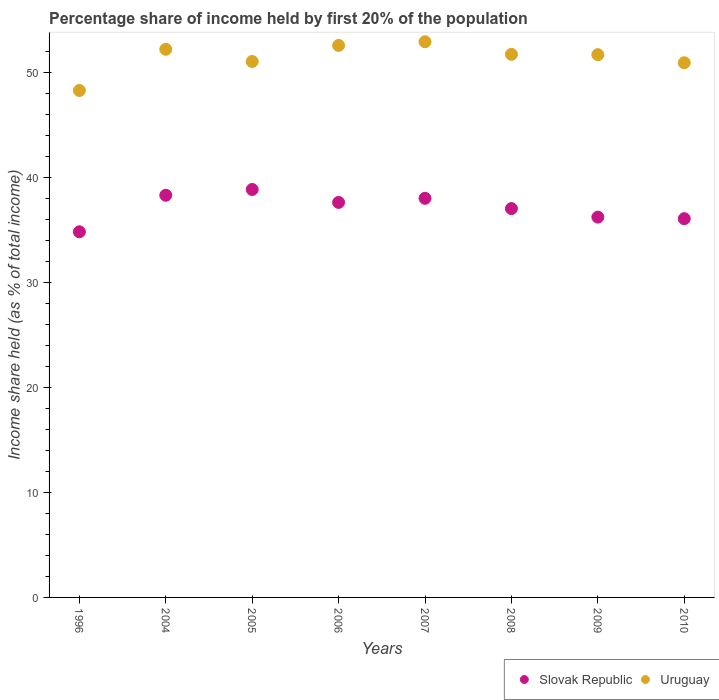How many different coloured dotlines are there?
Provide a short and direct response. 2. What is the share of income held by first 20% of the population in Uruguay in 2009?
Give a very brief answer. 51.69. Across all years, what is the maximum share of income held by first 20% of the population in Uruguay?
Provide a short and direct response. 52.92. Across all years, what is the minimum share of income held by first 20% of the population in Slovak Republic?
Your response must be concise. 34.82. What is the total share of income held by first 20% of the population in Slovak Republic in the graph?
Your answer should be very brief. 296.92. What is the difference between the share of income held by first 20% of the population in Slovak Republic in 2006 and that in 2007?
Give a very brief answer. -0.39. What is the difference between the share of income held by first 20% of the population in Slovak Republic in 2005 and the share of income held by first 20% of the population in Uruguay in 2007?
Keep it short and to the point. -14.07. What is the average share of income held by first 20% of the population in Slovak Republic per year?
Give a very brief answer. 37.11. In the year 2010, what is the difference between the share of income held by first 20% of the population in Slovak Republic and share of income held by first 20% of the population in Uruguay?
Offer a very short reply. -14.85. In how many years, is the share of income held by first 20% of the population in Slovak Republic greater than 48 %?
Provide a short and direct response. 0. What is the ratio of the share of income held by first 20% of the population in Uruguay in 2009 to that in 2010?
Your answer should be very brief. 1.02. Is the share of income held by first 20% of the population in Slovak Republic in 1996 less than that in 2007?
Your answer should be compact. Yes. Is the difference between the share of income held by first 20% of the population in Slovak Republic in 2005 and 2006 greater than the difference between the share of income held by first 20% of the population in Uruguay in 2005 and 2006?
Offer a very short reply. Yes. What is the difference between the highest and the second highest share of income held by first 20% of the population in Uruguay?
Make the answer very short. 0.35. What is the difference between the highest and the lowest share of income held by first 20% of the population in Uruguay?
Provide a short and direct response. 4.64. In how many years, is the share of income held by first 20% of the population in Slovak Republic greater than the average share of income held by first 20% of the population in Slovak Republic taken over all years?
Provide a succinct answer. 4. Is the sum of the share of income held by first 20% of the population in Uruguay in 2005 and 2008 greater than the maximum share of income held by first 20% of the population in Slovak Republic across all years?
Provide a short and direct response. Yes. Is the share of income held by first 20% of the population in Slovak Republic strictly less than the share of income held by first 20% of the population in Uruguay over the years?
Ensure brevity in your answer.  Yes. How many dotlines are there?
Make the answer very short. 2. How many years are there in the graph?
Your answer should be compact. 8. Are the values on the major ticks of Y-axis written in scientific E-notation?
Your answer should be very brief. No. Where does the legend appear in the graph?
Offer a terse response. Bottom right. What is the title of the graph?
Offer a terse response. Percentage share of income held by first 20% of the population. What is the label or title of the X-axis?
Provide a short and direct response. Years. What is the label or title of the Y-axis?
Provide a succinct answer. Income share held (as % of total income). What is the Income share held (as % of total income) of Slovak Republic in 1996?
Offer a very short reply. 34.82. What is the Income share held (as % of total income) of Uruguay in 1996?
Offer a very short reply. 48.28. What is the Income share held (as % of total income) in Slovak Republic in 2004?
Offer a terse response. 38.3. What is the Income share held (as % of total income) in Uruguay in 2004?
Your answer should be compact. 52.2. What is the Income share held (as % of total income) in Slovak Republic in 2005?
Your response must be concise. 38.85. What is the Income share held (as % of total income) in Uruguay in 2005?
Offer a terse response. 51.04. What is the Income share held (as % of total income) of Slovak Republic in 2006?
Offer a very short reply. 37.62. What is the Income share held (as % of total income) in Uruguay in 2006?
Provide a short and direct response. 52.57. What is the Income share held (as % of total income) of Slovak Republic in 2007?
Provide a short and direct response. 38.01. What is the Income share held (as % of total income) of Uruguay in 2007?
Give a very brief answer. 52.92. What is the Income share held (as % of total income) of Slovak Republic in 2008?
Make the answer very short. 37.03. What is the Income share held (as % of total income) of Uruguay in 2008?
Make the answer very short. 51.72. What is the Income share held (as % of total income) in Slovak Republic in 2009?
Keep it short and to the point. 36.22. What is the Income share held (as % of total income) in Uruguay in 2009?
Your answer should be very brief. 51.69. What is the Income share held (as % of total income) of Slovak Republic in 2010?
Give a very brief answer. 36.07. What is the Income share held (as % of total income) of Uruguay in 2010?
Offer a terse response. 50.92. Across all years, what is the maximum Income share held (as % of total income) of Slovak Republic?
Offer a very short reply. 38.85. Across all years, what is the maximum Income share held (as % of total income) of Uruguay?
Your response must be concise. 52.92. Across all years, what is the minimum Income share held (as % of total income) of Slovak Republic?
Your response must be concise. 34.82. Across all years, what is the minimum Income share held (as % of total income) in Uruguay?
Provide a short and direct response. 48.28. What is the total Income share held (as % of total income) of Slovak Republic in the graph?
Your answer should be compact. 296.92. What is the total Income share held (as % of total income) of Uruguay in the graph?
Give a very brief answer. 411.34. What is the difference between the Income share held (as % of total income) of Slovak Republic in 1996 and that in 2004?
Offer a very short reply. -3.48. What is the difference between the Income share held (as % of total income) in Uruguay in 1996 and that in 2004?
Offer a terse response. -3.92. What is the difference between the Income share held (as % of total income) of Slovak Republic in 1996 and that in 2005?
Keep it short and to the point. -4.03. What is the difference between the Income share held (as % of total income) in Uruguay in 1996 and that in 2005?
Your answer should be compact. -2.76. What is the difference between the Income share held (as % of total income) in Uruguay in 1996 and that in 2006?
Your answer should be very brief. -4.29. What is the difference between the Income share held (as % of total income) of Slovak Republic in 1996 and that in 2007?
Keep it short and to the point. -3.19. What is the difference between the Income share held (as % of total income) of Uruguay in 1996 and that in 2007?
Your response must be concise. -4.64. What is the difference between the Income share held (as % of total income) in Slovak Republic in 1996 and that in 2008?
Provide a succinct answer. -2.21. What is the difference between the Income share held (as % of total income) of Uruguay in 1996 and that in 2008?
Provide a short and direct response. -3.44. What is the difference between the Income share held (as % of total income) of Uruguay in 1996 and that in 2009?
Your answer should be compact. -3.41. What is the difference between the Income share held (as % of total income) in Slovak Republic in 1996 and that in 2010?
Offer a terse response. -1.25. What is the difference between the Income share held (as % of total income) in Uruguay in 1996 and that in 2010?
Your response must be concise. -2.64. What is the difference between the Income share held (as % of total income) in Slovak Republic in 2004 and that in 2005?
Ensure brevity in your answer.  -0.55. What is the difference between the Income share held (as % of total income) of Uruguay in 2004 and that in 2005?
Your answer should be very brief. 1.16. What is the difference between the Income share held (as % of total income) in Slovak Republic in 2004 and that in 2006?
Your response must be concise. 0.68. What is the difference between the Income share held (as % of total income) of Uruguay in 2004 and that in 2006?
Your response must be concise. -0.37. What is the difference between the Income share held (as % of total income) in Slovak Republic in 2004 and that in 2007?
Give a very brief answer. 0.29. What is the difference between the Income share held (as % of total income) in Uruguay in 2004 and that in 2007?
Your response must be concise. -0.72. What is the difference between the Income share held (as % of total income) of Slovak Republic in 2004 and that in 2008?
Provide a succinct answer. 1.27. What is the difference between the Income share held (as % of total income) in Uruguay in 2004 and that in 2008?
Your answer should be compact. 0.48. What is the difference between the Income share held (as % of total income) of Slovak Republic in 2004 and that in 2009?
Your response must be concise. 2.08. What is the difference between the Income share held (as % of total income) of Uruguay in 2004 and that in 2009?
Offer a terse response. 0.51. What is the difference between the Income share held (as % of total income) in Slovak Republic in 2004 and that in 2010?
Keep it short and to the point. 2.23. What is the difference between the Income share held (as % of total income) in Uruguay in 2004 and that in 2010?
Provide a short and direct response. 1.28. What is the difference between the Income share held (as % of total income) in Slovak Republic in 2005 and that in 2006?
Provide a succinct answer. 1.23. What is the difference between the Income share held (as % of total income) in Uruguay in 2005 and that in 2006?
Provide a succinct answer. -1.53. What is the difference between the Income share held (as % of total income) of Slovak Republic in 2005 and that in 2007?
Make the answer very short. 0.84. What is the difference between the Income share held (as % of total income) in Uruguay in 2005 and that in 2007?
Ensure brevity in your answer.  -1.88. What is the difference between the Income share held (as % of total income) in Slovak Republic in 2005 and that in 2008?
Offer a terse response. 1.82. What is the difference between the Income share held (as % of total income) of Uruguay in 2005 and that in 2008?
Give a very brief answer. -0.68. What is the difference between the Income share held (as % of total income) in Slovak Republic in 2005 and that in 2009?
Offer a terse response. 2.63. What is the difference between the Income share held (as % of total income) of Uruguay in 2005 and that in 2009?
Make the answer very short. -0.65. What is the difference between the Income share held (as % of total income) of Slovak Republic in 2005 and that in 2010?
Provide a succinct answer. 2.78. What is the difference between the Income share held (as % of total income) of Uruguay in 2005 and that in 2010?
Provide a short and direct response. 0.12. What is the difference between the Income share held (as % of total income) of Slovak Republic in 2006 and that in 2007?
Offer a terse response. -0.39. What is the difference between the Income share held (as % of total income) in Uruguay in 2006 and that in 2007?
Provide a short and direct response. -0.35. What is the difference between the Income share held (as % of total income) of Slovak Republic in 2006 and that in 2008?
Keep it short and to the point. 0.59. What is the difference between the Income share held (as % of total income) of Slovak Republic in 2006 and that in 2009?
Offer a terse response. 1.4. What is the difference between the Income share held (as % of total income) in Uruguay in 2006 and that in 2009?
Give a very brief answer. 0.88. What is the difference between the Income share held (as % of total income) in Slovak Republic in 2006 and that in 2010?
Your answer should be very brief. 1.55. What is the difference between the Income share held (as % of total income) in Uruguay in 2006 and that in 2010?
Keep it short and to the point. 1.65. What is the difference between the Income share held (as % of total income) in Uruguay in 2007 and that in 2008?
Keep it short and to the point. 1.2. What is the difference between the Income share held (as % of total income) in Slovak Republic in 2007 and that in 2009?
Your response must be concise. 1.79. What is the difference between the Income share held (as % of total income) in Uruguay in 2007 and that in 2009?
Your answer should be compact. 1.23. What is the difference between the Income share held (as % of total income) in Slovak Republic in 2007 and that in 2010?
Keep it short and to the point. 1.94. What is the difference between the Income share held (as % of total income) of Uruguay in 2007 and that in 2010?
Provide a succinct answer. 2. What is the difference between the Income share held (as % of total income) in Slovak Republic in 2008 and that in 2009?
Provide a succinct answer. 0.81. What is the difference between the Income share held (as % of total income) in Uruguay in 2008 and that in 2009?
Offer a very short reply. 0.03. What is the difference between the Income share held (as % of total income) in Uruguay in 2008 and that in 2010?
Provide a succinct answer. 0.8. What is the difference between the Income share held (as % of total income) in Slovak Republic in 2009 and that in 2010?
Keep it short and to the point. 0.15. What is the difference between the Income share held (as % of total income) in Uruguay in 2009 and that in 2010?
Your answer should be compact. 0.77. What is the difference between the Income share held (as % of total income) of Slovak Republic in 1996 and the Income share held (as % of total income) of Uruguay in 2004?
Provide a succinct answer. -17.38. What is the difference between the Income share held (as % of total income) in Slovak Republic in 1996 and the Income share held (as % of total income) in Uruguay in 2005?
Keep it short and to the point. -16.22. What is the difference between the Income share held (as % of total income) of Slovak Republic in 1996 and the Income share held (as % of total income) of Uruguay in 2006?
Your answer should be compact. -17.75. What is the difference between the Income share held (as % of total income) of Slovak Republic in 1996 and the Income share held (as % of total income) of Uruguay in 2007?
Provide a succinct answer. -18.1. What is the difference between the Income share held (as % of total income) in Slovak Republic in 1996 and the Income share held (as % of total income) in Uruguay in 2008?
Offer a very short reply. -16.9. What is the difference between the Income share held (as % of total income) of Slovak Republic in 1996 and the Income share held (as % of total income) of Uruguay in 2009?
Ensure brevity in your answer.  -16.87. What is the difference between the Income share held (as % of total income) of Slovak Republic in 1996 and the Income share held (as % of total income) of Uruguay in 2010?
Your answer should be very brief. -16.1. What is the difference between the Income share held (as % of total income) of Slovak Republic in 2004 and the Income share held (as % of total income) of Uruguay in 2005?
Ensure brevity in your answer.  -12.74. What is the difference between the Income share held (as % of total income) of Slovak Republic in 2004 and the Income share held (as % of total income) of Uruguay in 2006?
Offer a very short reply. -14.27. What is the difference between the Income share held (as % of total income) in Slovak Republic in 2004 and the Income share held (as % of total income) in Uruguay in 2007?
Provide a succinct answer. -14.62. What is the difference between the Income share held (as % of total income) in Slovak Republic in 2004 and the Income share held (as % of total income) in Uruguay in 2008?
Offer a very short reply. -13.42. What is the difference between the Income share held (as % of total income) in Slovak Republic in 2004 and the Income share held (as % of total income) in Uruguay in 2009?
Ensure brevity in your answer.  -13.39. What is the difference between the Income share held (as % of total income) in Slovak Republic in 2004 and the Income share held (as % of total income) in Uruguay in 2010?
Your response must be concise. -12.62. What is the difference between the Income share held (as % of total income) of Slovak Republic in 2005 and the Income share held (as % of total income) of Uruguay in 2006?
Your answer should be compact. -13.72. What is the difference between the Income share held (as % of total income) in Slovak Republic in 2005 and the Income share held (as % of total income) in Uruguay in 2007?
Offer a terse response. -14.07. What is the difference between the Income share held (as % of total income) in Slovak Republic in 2005 and the Income share held (as % of total income) in Uruguay in 2008?
Your answer should be compact. -12.87. What is the difference between the Income share held (as % of total income) in Slovak Republic in 2005 and the Income share held (as % of total income) in Uruguay in 2009?
Give a very brief answer. -12.84. What is the difference between the Income share held (as % of total income) in Slovak Republic in 2005 and the Income share held (as % of total income) in Uruguay in 2010?
Your response must be concise. -12.07. What is the difference between the Income share held (as % of total income) in Slovak Republic in 2006 and the Income share held (as % of total income) in Uruguay in 2007?
Keep it short and to the point. -15.3. What is the difference between the Income share held (as % of total income) of Slovak Republic in 2006 and the Income share held (as % of total income) of Uruguay in 2008?
Make the answer very short. -14.1. What is the difference between the Income share held (as % of total income) of Slovak Republic in 2006 and the Income share held (as % of total income) of Uruguay in 2009?
Your response must be concise. -14.07. What is the difference between the Income share held (as % of total income) in Slovak Republic in 2006 and the Income share held (as % of total income) in Uruguay in 2010?
Your answer should be compact. -13.3. What is the difference between the Income share held (as % of total income) of Slovak Republic in 2007 and the Income share held (as % of total income) of Uruguay in 2008?
Give a very brief answer. -13.71. What is the difference between the Income share held (as % of total income) in Slovak Republic in 2007 and the Income share held (as % of total income) in Uruguay in 2009?
Your answer should be compact. -13.68. What is the difference between the Income share held (as % of total income) of Slovak Republic in 2007 and the Income share held (as % of total income) of Uruguay in 2010?
Ensure brevity in your answer.  -12.91. What is the difference between the Income share held (as % of total income) of Slovak Republic in 2008 and the Income share held (as % of total income) of Uruguay in 2009?
Offer a very short reply. -14.66. What is the difference between the Income share held (as % of total income) of Slovak Republic in 2008 and the Income share held (as % of total income) of Uruguay in 2010?
Make the answer very short. -13.89. What is the difference between the Income share held (as % of total income) in Slovak Republic in 2009 and the Income share held (as % of total income) in Uruguay in 2010?
Your response must be concise. -14.7. What is the average Income share held (as % of total income) of Slovak Republic per year?
Provide a short and direct response. 37.12. What is the average Income share held (as % of total income) in Uruguay per year?
Offer a very short reply. 51.42. In the year 1996, what is the difference between the Income share held (as % of total income) in Slovak Republic and Income share held (as % of total income) in Uruguay?
Your answer should be very brief. -13.46. In the year 2004, what is the difference between the Income share held (as % of total income) of Slovak Republic and Income share held (as % of total income) of Uruguay?
Your answer should be compact. -13.9. In the year 2005, what is the difference between the Income share held (as % of total income) in Slovak Republic and Income share held (as % of total income) in Uruguay?
Ensure brevity in your answer.  -12.19. In the year 2006, what is the difference between the Income share held (as % of total income) of Slovak Republic and Income share held (as % of total income) of Uruguay?
Your response must be concise. -14.95. In the year 2007, what is the difference between the Income share held (as % of total income) of Slovak Republic and Income share held (as % of total income) of Uruguay?
Provide a succinct answer. -14.91. In the year 2008, what is the difference between the Income share held (as % of total income) of Slovak Republic and Income share held (as % of total income) of Uruguay?
Keep it short and to the point. -14.69. In the year 2009, what is the difference between the Income share held (as % of total income) of Slovak Republic and Income share held (as % of total income) of Uruguay?
Ensure brevity in your answer.  -15.47. In the year 2010, what is the difference between the Income share held (as % of total income) of Slovak Republic and Income share held (as % of total income) of Uruguay?
Ensure brevity in your answer.  -14.85. What is the ratio of the Income share held (as % of total income) in Uruguay in 1996 to that in 2004?
Provide a succinct answer. 0.92. What is the ratio of the Income share held (as % of total income) of Slovak Republic in 1996 to that in 2005?
Keep it short and to the point. 0.9. What is the ratio of the Income share held (as % of total income) of Uruguay in 1996 to that in 2005?
Offer a terse response. 0.95. What is the ratio of the Income share held (as % of total income) of Slovak Republic in 1996 to that in 2006?
Offer a very short reply. 0.93. What is the ratio of the Income share held (as % of total income) of Uruguay in 1996 to that in 2006?
Provide a short and direct response. 0.92. What is the ratio of the Income share held (as % of total income) of Slovak Republic in 1996 to that in 2007?
Your response must be concise. 0.92. What is the ratio of the Income share held (as % of total income) in Uruguay in 1996 to that in 2007?
Make the answer very short. 0.91. What is the ratio of the Income share held (as % of total income) of Slovak Republic in 1996 to that in 2008?
Give a very brief answer. 0.94. What is the ratio of the Income share held (as % of total income) in Uruguay in 1996 to that in 2008?
Offer a terse response. 0.93. What is the ratio of the Income share held (as % of total income) in Slovak Republic in 1996 to that in 2009?
Keep it short and to the point. 0.96. What is the ratio of the Income share held (as % of total income) of Uruguay in 1996 to that in 2009?
Provide a succinct answer. 0.93. What is the ratio of the Income share held (as % of total income) of Slovak Republic in 1996 to that in 2010?
Your response must be concise. 0.97. What is the ratio of the Income share held (as % of total income) in Uruguay in 1996 to that in 2010?
Provide a succinct answer. 0.95. What is the ratio of the Income share held (as % of total income) in Slovak Republic in 2004 to that in 2005?
Offer a very short reply. 0.99. What is the ratio of the Income share held (as % of total income) of Uruguay in 2004 to that in 2005?
Ensure brevity in your answer.  1.02. What is the ratio of the Income share held (as % of total income) in Slovak Republic in 2004 to that in 2006?
Your answer should be very brief. 1.02. What is the ratio of the Income share held (as % of total income) of Uruguay in 2004 to that in 2006?
Your response must be concise. 0.99. What is the ratio of the Income share held (as % of total income) in Slovak Republic in 2004 to that in 2007?
Your response must be concise. 1.01. What is the ratio of the Income share held (as % of total income) in Uruguay in 2004 to that in 2007?
Offer a very short reply. 0.99. What is the ratio of the Income share held (as % of total income) in Slovak Republic in 2004 to that in 2008?
Keep it short and to the point. 1.03. What is the ratio of the Income share held (as % of total income) in Uruguay in 2004 to that in 2008?
Your answer should be compact. 1.01. What is the ratio of the Income share held (as % of total income) in Slovak Republic in 2004 to that in 2009?
Your answer should be compact. 1.06. What is the ratio of the Income share held (as % of total income) in Uruguay in 2004 to that in 2009?
Provide a succinct answer. 1.01. What is the ratio of the Income share held (as % of total income) of Slovak Republic in 2004 to that in 2010?
Give a very brief answer. 1.06. What is the ratio of the Income share held (as % of total income) of Uruguay in 2004 to that in 2010?
Give a very brief answer. 1.03. What is the ratio of the Income share held (as % of total income) in Slovak Republic in 2005 to that in 2006?
Your answer should be compact. 1.03. What is the ratio of the Income share held (as % of total income) of Uruguay in 2005 to that in 2006?
Give a very brief answer. 0.97. What is the ratio of the Income share held (as % of total income) in Slovak Republic in 2005 to that in 2007?
Your answer should be compact. 1.02. What is the ratio of the Income share held (as % of total income) in Uruguay in 2005 to that in 2007?
Make the answer very short. 0.96. What is the ratio of the Income share held (as % of total income) in Slovak Republic in 2005 to that in 2008?
Make the answer very short. 1.05. What is the ratio of the Income share held (as % of total income) in Uruguay in 2005 to that in 2008?
Provide a succinct answer. 0.99. What is the ratio of the Income share held (as % of total income) of Slovak Republic in 2005 to that in 2009?
Keep it short and to the point. 1.07. What is the ratio of the Income share held (as % of total income) of Uruguay in 2005 to that in 2009?
Your answer should be very brief. 0.99. What is the ratio of the Income share held (as % of total income) of Slovak Republic in 2005 to that in 2010?
Keep it short and to the point. 1.08. What is the ratio of the Income share held (as % of total income) in Slovak Republic in 2006 to that in 2007?
Give a very brief answer. 0.99. What is the ratio of the Income share held (as % of total income) of Slovak Republic in 2006 to that in 2008?
Provide a succinct answer. 1.02. What is the ratio of the Income share held (as % of total income) in Uruguay in 2006 to that in 2008?
Give a very brief answer. 1.02. What is the ratio of the Income share held (as % of total income) of Slovak Republic in 2006 to that in 2009?
Your answer should be compact. 1.04. What is the ratio of the Income share held (as % of total income) of Uruguay in 2006 to that in 2009?
Give a very brief answer. 1.02. What is the ratio of the Income share held (as % of total income) of Slovak Republic in 2006 to that in 2010?
Ensure brevity in your answer.  1.04. What is the ratio of the Income share held (as % of total income) of Uruguay in 2006 to that in 2010?
Offer a very short reply. 1.03. What is the ratio of the Income share held (as % of total income) in Slovak Republic in 2007 to that in 2008?
Ensure brevity in your answer.  1.03. What is the ratio of the Income share held (as % of total income) in Uruguay in 2007 to that in 2008?
Your answer should be very brief. 1.02. What is the ratio of the Income share held (as % of total income) of Slovak Republic in 2007 to that in 2009?
Offer a terse response. 1.05. What is the ratio of the Income share held (as % of total income) of Uruguay in 2007 to that in 2009?
Your answer should be compact. 1.02. What is the ratio of the Income share held (as % of total income) in Slovak Republic in 2007 to that in 2010?
Provide a short and direct response. 1.05. What is the ratio of the Income share held (as % of total income) of Uruguay in 2007 to that in 2010?
Keep it short and to the point. 1.04. What is the ratio of the Income share held (as % of total income) of Slovak Republic in 2008 to that in 2009?
Your answer should be very brief. 1.02. What is the ratio of the Income share held (as % of total income) in Slovak Republic in 2008 to that in 2010?
Offer a very short reply. 1.03. What is the ratio of the Income share held (as % of total income) in Uruguay in 2008 to that in 2010?
Offer a terse response. 1.02. What is the ratio of the Income share held (as % of total income) in Slovak Republic in 2009 to that in 2010?
Your response must be concise. 1. What is the ratio of the Income share held (as % of total income) of Uruguay in 2009 to that in 2010?
Ensure brevity in your answer.  1.02. What is the difference between the highest and the second highest Income share held (as % of total income) in Slovak Republic?
Keep it short and to the point. 0.55. What is the difference between the highest and the second highest Income share held (as % of total income) of Uruguay?
Your response must be concise. 0.35. What is the difference between the highest and the lowest Income share held (as % of total income) of Slovak Republic?
Provide a short and direct response. 4.03. What is the difference between the highest and the lowest Income share held (as % of total income) of Uruguay?
Make the answer very short. 4.64. 